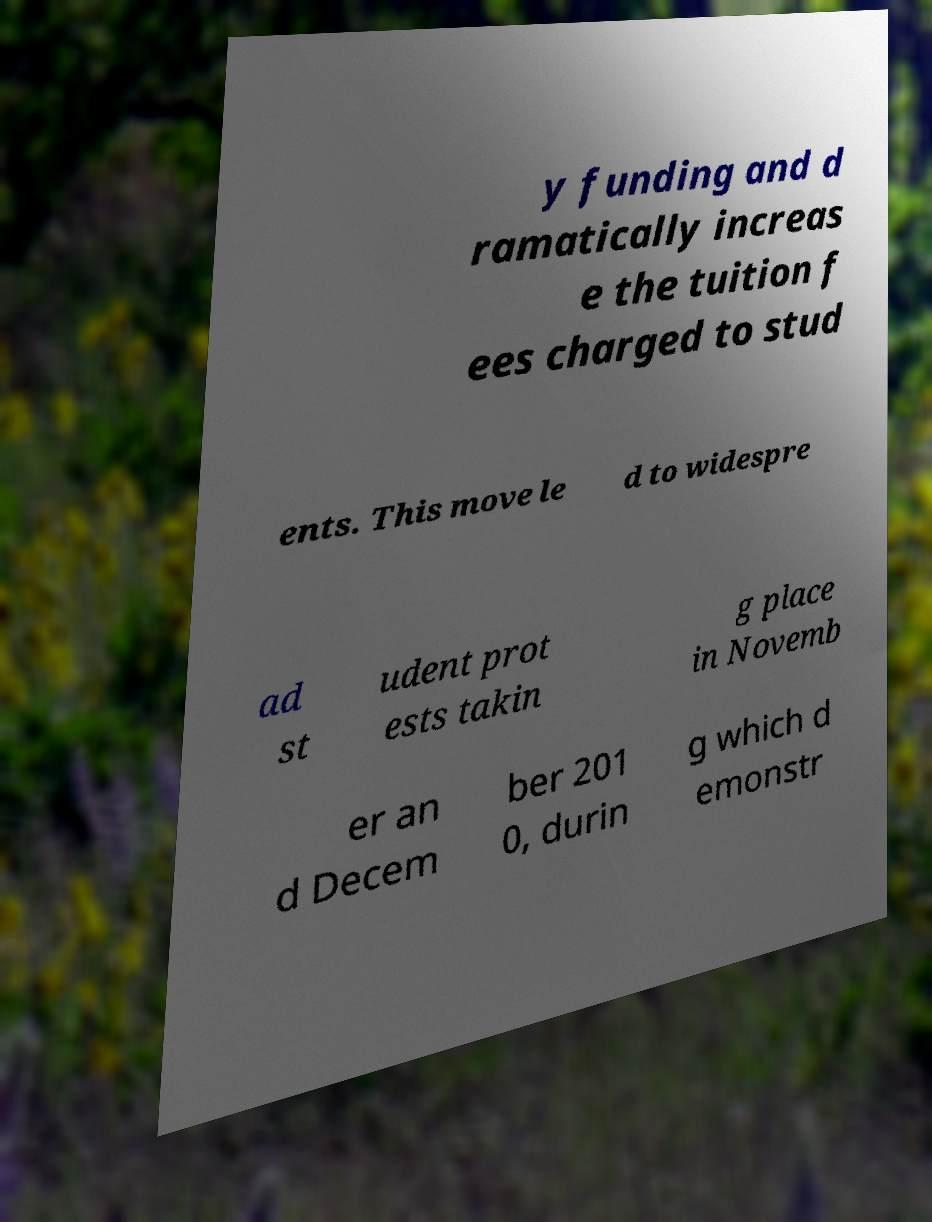Could you assist in decoding the text presented in this image and type it out clearly? y funding and d ramatically increas e the tuition f ees charged to stud ents. This move le d to widespre ad st udent prot ests takin g place in Novemb er an d Decem ber 201 0, durin g which d emonstr 